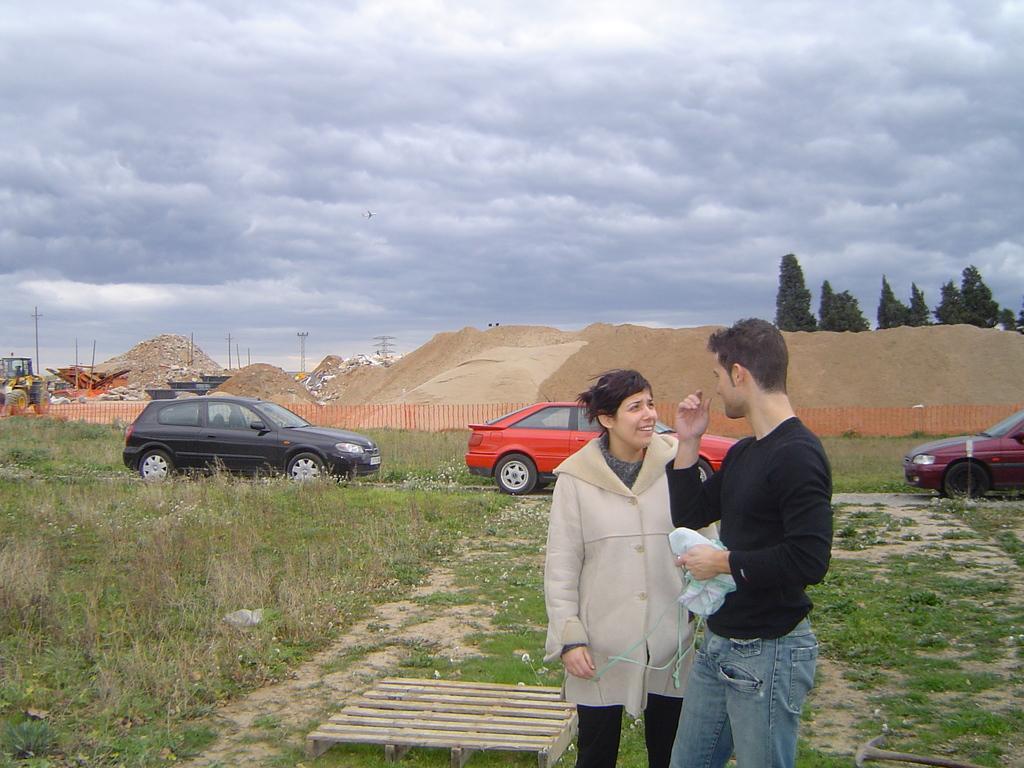Can you describe this image briefly? There is a man and a woman standing on the ground. This is grass and there are cars. In the background we can see poles, trees, sand, fence, vehicle, and sky with clouds. 